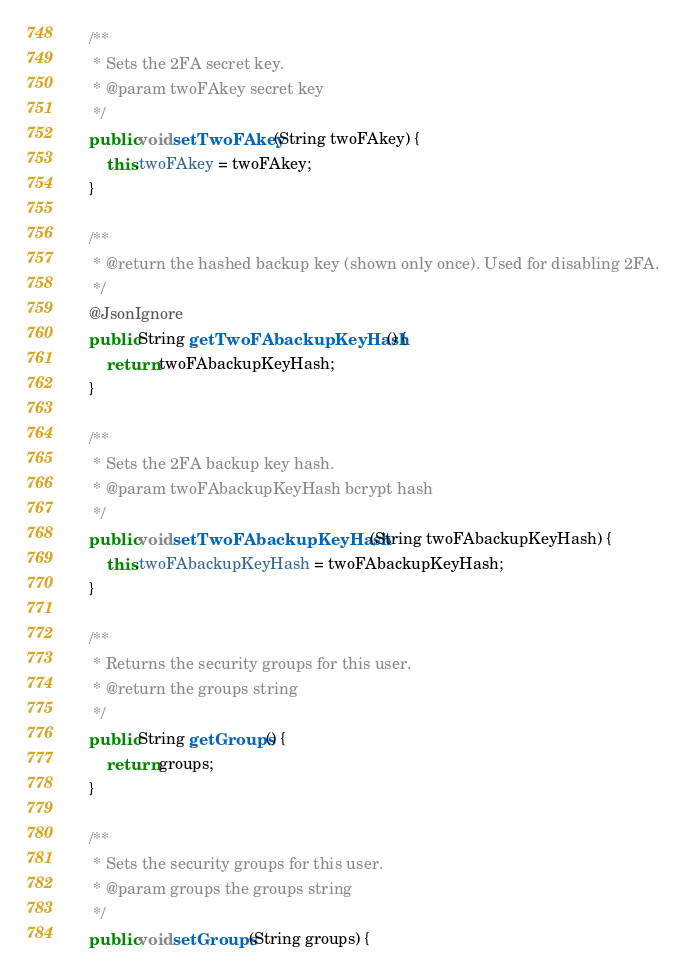<code> <loc_0><loc_0><loc_500><loc_500><_Java_>
	/**
	 * Sets the 2FA secret key.
	 * @param twoFAkey secret key
	 */
	public void setTwoFAkey(String twoFAkey) {
		this.twoFAkey = twoFAkey;
	}

	/**
	 * @return the hashed backup key (shown only once). Used for disabling 2FA.
	 */
	@JsonIgnore
	public String getTwoFAbackupKeyHash() {
		return twoFAbackupKeyHash;
	}

	/**
	 * Sets the 2FA backup key hash.
	 * @param twoFAbackupKeyHash bcrypt hash
	 */
	public void setTwoFAbackupKeyHash(String twoFAbackupKeyHash) {
		this.twoFAbackupKeyHash = twoFAbackupKeyHash;
	}

	/**
	 * Returns the security groups for this user.
	 * @return the groups string
	 */
	public String getGroups() {
		return groups;
	}

	/**
	 * Sets the security groups for this user.
	 * @param groups the groups string
	 */
	public void setGroups(String groups) {</code> 